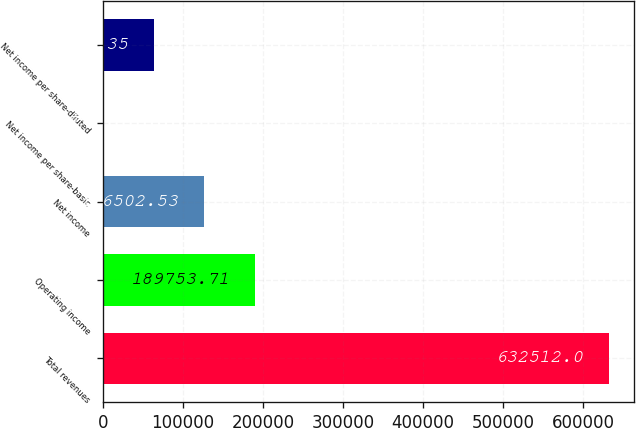<chart> <loc_0><loc_0><loc_500><loc_500><bar_chart><fcel>Total revenues<fcel>Operating income<fcel>Net income<fcel>Net income per share-basic<fcel>Net income per share-diluted<nl><fcel>632512<fcel>189754<fcel>126503<fcel>0.17<fcel>63251.3<nl></chart> 